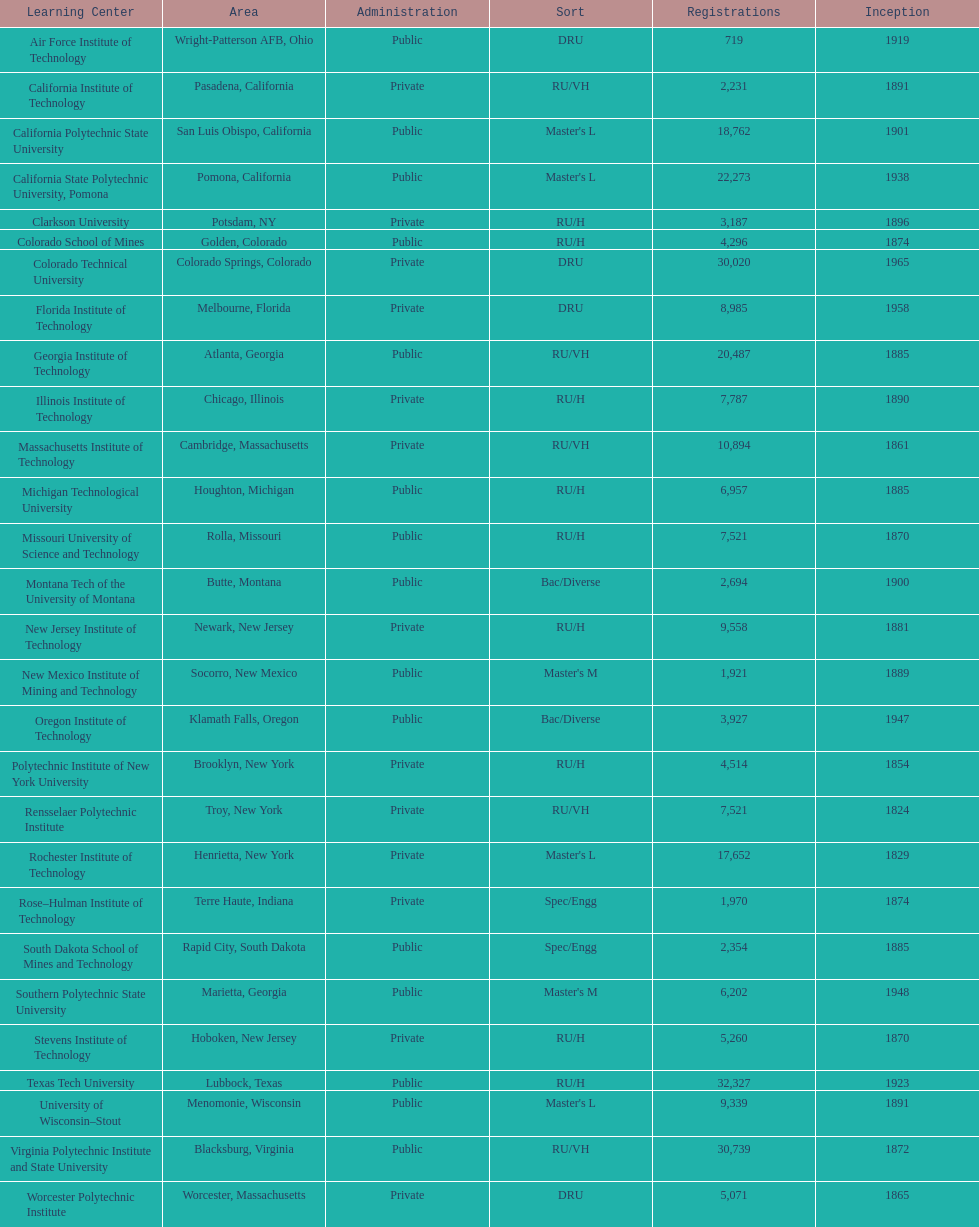What's the number of schools represented in the table? 28. Parse the full table. {'header': ['Learning Center', 'Area', 'Administration', 'Sort', 'Registrations', 'Inception'], 'rows': [['Air Force Institute of Technology', 'Wright-Patterson AFB, Ohio', 'Public', 'DRU', '719', '1919'], ['California Institute of Technology', 'Pasadena, California', 'Private', 'RU/VH', '2,231', '1891'], ['California Polytechnic State University', 'San Luis Obispo, California', 'Public', "Master's L", '18,762', '1901'], ['California State Polytechnic University, Pomona', 'Pomona, California', 'Public', "Master's L", '22,273', '1938'], ['Clarkson University', 'Potsdam, NY', 'Private', 'RU/H', '3,187', '1896'], ['Colorado School of Mines', 'Golden, Colorado', 'Public', 'RU/H', '4,296', '1874'], ['Colorado Technical University', 'Colorado Springs, Colorado', 'Private', 'DRU', '30,020', '1965'], ['Florida Institute of Technology', 'Melbourne, Florida', 'Private', 'DRU', '8,985', '1958'], ['Georgia Institute of Technology', 'Atlanta, Georgia', 'Public', 'RU/VH', '20,487', '1885'], ['Illinois Institute of Technology', 'Chicago, Illinois', 'Private', 'RU/H', '7,787', '1890'], ['Massachusetts Institute of Technology', 'Cambridge, Massachusetts', 'Private', 'RU/VH', '10,894', '1861'], ['Michigan Technological University', 'Houghton, Michigan', 'Public', 'RU/H', '6,957', '1885'], ['Missouri University of Science and Technology', 'Rolla, Missouri', 'Public', 'RU/H', '7,521', '1870'], ['Montana Tech of the University of Montana', 'Butte, Montana', 'Public', 'Bac/Diverse', '2,694', '1900'], ['New Jersey Institute of Technology', 'Newark, New Jersey', 'Private', 'RU/H', '9,558', '1881'], ['New Mexico Institute of Mining and Technology', 'Socorro, New Mexico', 'Public', "Master's M", '1,921', '1889'], ['Oregon Institute of Technology', 'Klamath Falls, Oregon', 'Public', 'Bac/Diverse', '3,927', '1947'], ['Polytechnic Institute of New York University', 'Brooklyn, New York', 'Private', 'RU/H', '4,514', '1854'], ['Rensselaer Polytechnic Institute', 'Troy, New York', 'Private', 'RU/VH', '7,521', '1824'], ['Rochester Institute of Technology', 'Henrietta, New York', 'Private', "Master's L", '17,652', '1829'], ['Rose–Hulman Institute of Technology', 'Terre Haute, Indiana', 'Private', 'Spec/Engg', '1,970', '1874'], ['South Dakota School of Mines and Technology', 'Rapid City, South Dakota', 'Public', 'Spec/Engg', '2,354', '1885'], ['Southern Polytechnic State University', 'Marietta, Georgia', 'Public', "Master's M", '6,202', '1948'], ['Stevens Institute of Technology', 'Hoboken, New Jersey', 'Private', 'RU/H', '5,260', '1870'], ['Texas Tech University', 'Lubbock, Texas', 'Public', 'RU/H', '32,327', '1923'], ['University of Wisconsin–Stout', 'Menomonie, Wisconsin', 'Public', "Master's L", '9,339', '1891'], ['Virginia Polytechnic Institute and State University', 'Blacksburg, Virginia', 'Public', 'RU/VH', '30,739', '1872'], ['Worcester Polytechnic Institute', 'Worcester, Massachusetts', 'Private', 'DRU', '5,071', '1865']]} 